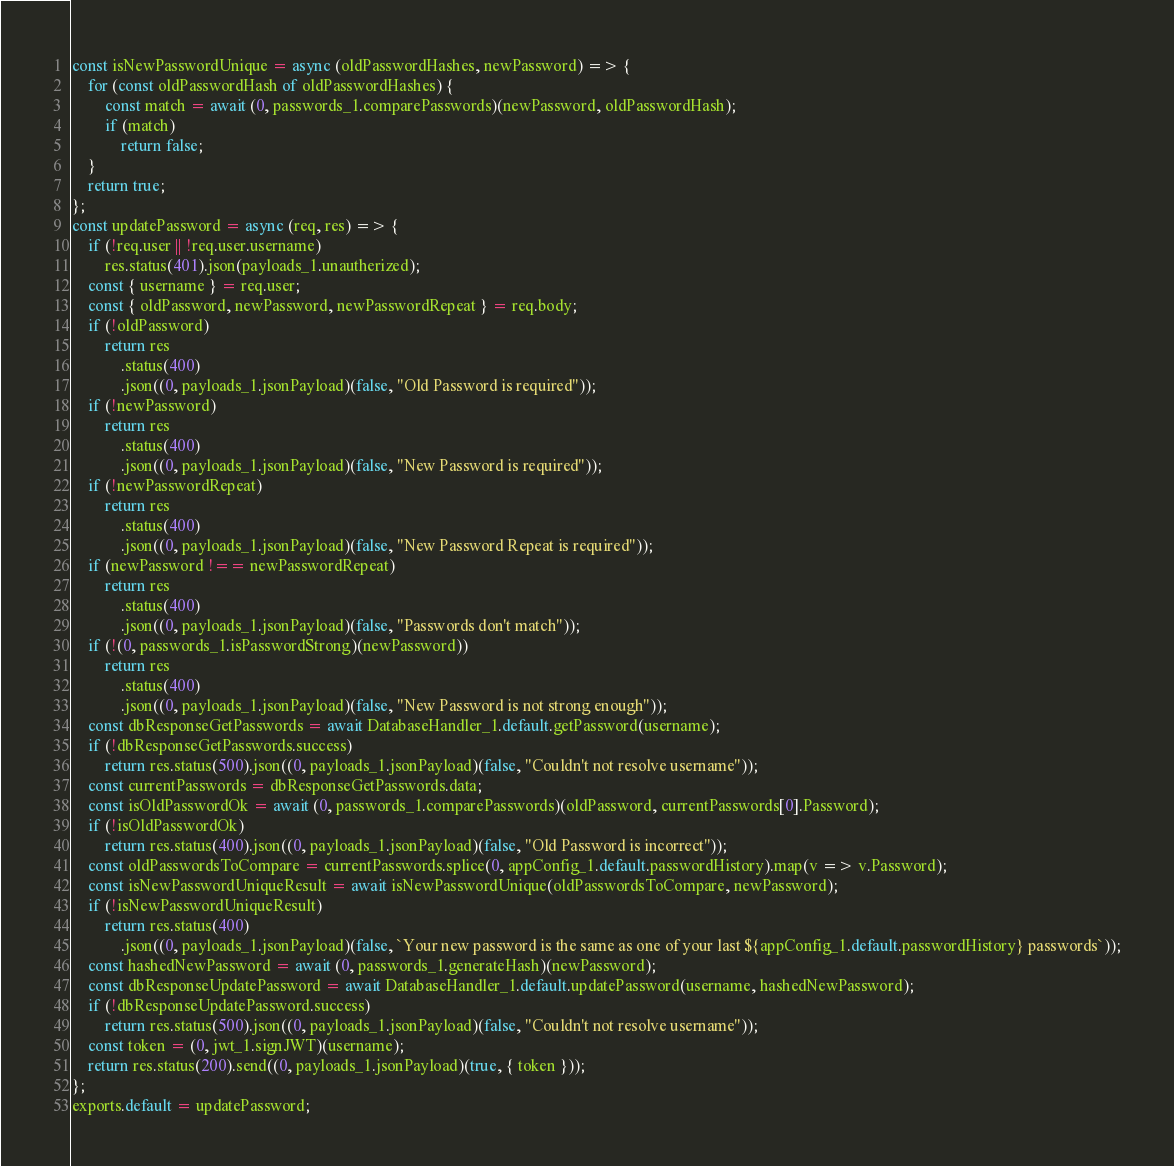<code> <loc_0><loc_0><loc_500><loc_500><_JavaScript_>const isNewPasswordUnique = async (oldPasswordHashes, newPassword) => {
    for (const oldPasswordHash of oldPasswordHashes) {
        const match = await (0, passwords_1.comparePasswords)(newPassword, oldPasswordHash);
        if (match)
            return false;
    }
    return true;
};
const updatePassword = async (req, res) => {
    if (!req.user || !req.user.username)
        res.status(401).json(payloads_1.unautherized);
    const { username } = req.user;
    const { oldPassword, newPassword, newPasswordRepeat } = req.body;
    if (!oldPassword)
        return res
            .status(400)
            .json((0, payloads_1.jsonPayload)(false, "Old Password is required"));
    if (!newPassword)
        return res
            .status(400)
            .json((0, payloads_1.jsonPayload)(false, "New Password is required"));
    if (!newPasswordRepeat)
        return res
            .status(400)
            .json((0, payloads_1.jsonPayload)(false, "New Password Repeat is required"));
    if (newPassword !== newPasswordRepeat)
        return res
            .status(400)
            .json((0, payloads_1.jsonPayload)(false, "Passwords don't match"));
    if (!(0, passwords_1.isPasswordStrong)(newPassword))
        return res
            .status(400)
            .json((0, payloads_1.jsonPayload)(false, "New Password is not strong enough"));
    const dbResponseGetPasswords = await DatabaseHandler_1.default.getPassword(username);
    if (!dbResponseGetPasswords.success)
        return res.status(500).json((0, payloads_1.jsonPayload)(false, "Couldn't not resolve username"));
    const currentPasswords = dbResponseGetPasswords.data;
    const isOldPasswordOk = await (0, passwords_1.comparePasswords)(oldPassword, currentPasswords[0].Password);
    if (!isOldPasswordOk)
        return res.status(400).json((0, payloads_1.jsonPayload)(false, "Old Password is incorrect"));
    const oldPasswordsToCompare = currentPasswords.splice(0, appConfig_1.default.passwordHistory).map(v => v.Password);
    const isNewPasswordUniqueResult = await isNewPasswordUnique(oldPasswordsToCompare, newPassword);
    if (!isNewPasswordUniqueResult)
        return res.status(400)
            .json((0, payloads_1.jsonPayload)(false, `Your new password is the same as one of your last ${appConfig_1.default.passwordHistory} passwords`));
    const hashedNewPassword = await (0, passwords_1.generateHash)(newPassword);
    const dbResponseUpdatePassword = await DatabaseHandler_1.default.updatePassword(username, hashedNewPassword);
    if (!dbResponseUpdatePassword.success)
        return res.status(500).json((0, payloads_1.jsonPayload)(false, "Couldn't not resolve username"));
    const token = (0, jwt_1.signJWT)(username);
    return res.status(200).send((0, payloads_1.jsonPayload)(true, { token }));
};
exports.default = updatePassword;
</code> 